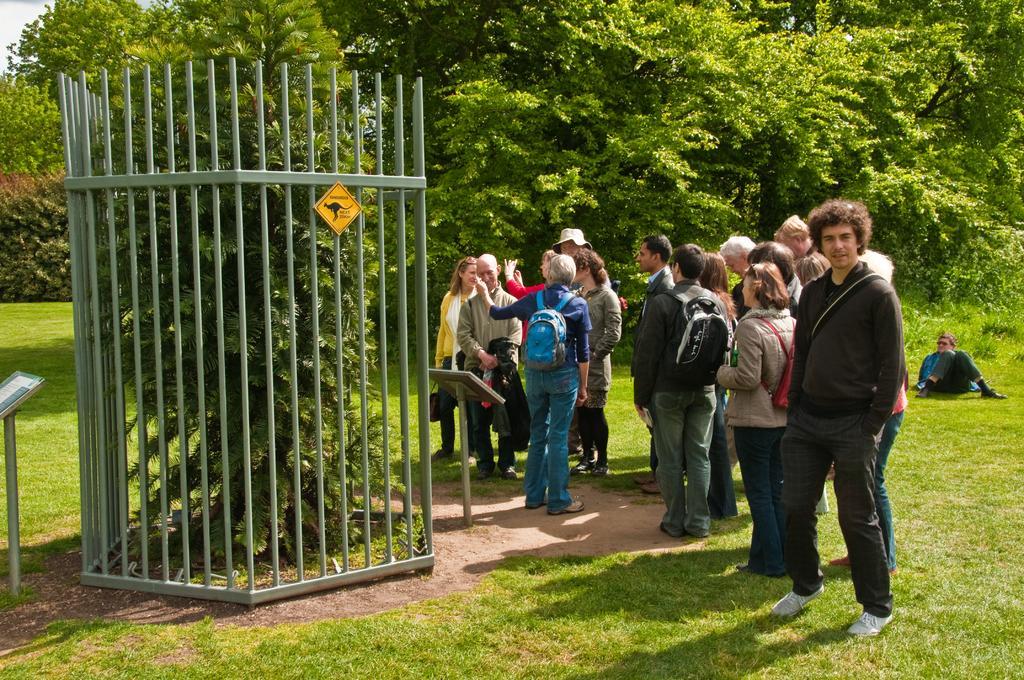Please provide a concise description of this image. In this image we can see the people standing. We can also see the trees, grille, stands and also the grass. There is a person sitting in the background. 